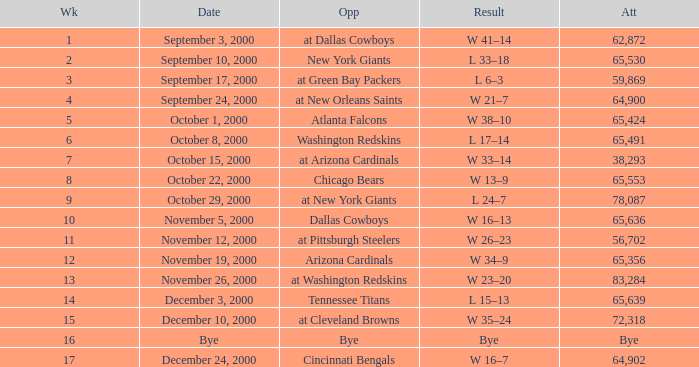What was the attendance for week 2? 65530.0. 